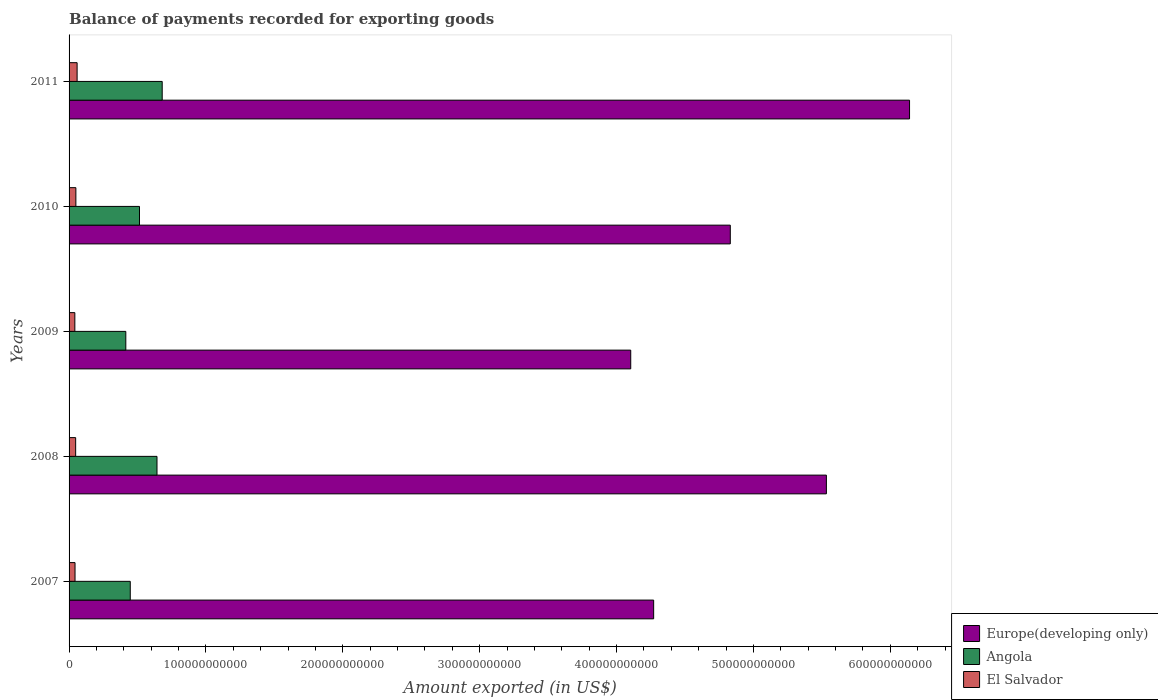How many groups of bars are there?
Give a very brief answer. 5. How many bars are there on the 1st tick from the bottom?
Ensure brevity in your answer.  3. What is the label of the 5th group of bars from the top?
Your answer should be very brief. 2007. In how many cases, is the number of bars for a given year not equal to the number of legend labels?
Make the answer very short. 0. What is the amount exported in Europe(developing only) in 2007?
Your response must be concise. 4.27e+11. Across all years, what is the maximum amount exported in Angola?
Provide a succinct answer. 6.80e+1. Across all years, what is the minimum amount exported in Europe(developing only)?
Provide a short and direct response. 4.10e+11. What is the total amount exported in Europe(developing only) in the graph?
Offer a very short reply. 2.49e+12. What is the difference between the amount exported in Europe(developing only) in 2007 and that in 2009?
Offer a terse response. 1.67e+1. What is the difference between the amount exported in El Salvador in 2010 and the amount exported in Angola in 2008?
Provide a short and direct response. -5.93e+1. What is the average amount exported in Europe(developing only) per year?
Your answer should be compact. 4.98e+11. In the year 2007, what is the difference between the amount exported in Angola and amount exported in El Salvador?
Your answer should be very brief. 4.04e+1. In how many years, is the amount exported in Angola greater than 540000000000 US$?
Provide a succinct answer. 0. What is the ratio of the amount exported in Angola in 2007 to that in 2010?
Offer a very short reply. 0.87. Is the amount exported in Europe(developing only) in 2008 less than that in 2010?
Make the answer very short. No. What is the difference between the highest and the second highest amount exported in El Salvador?
Give a very brief answer. 9.07e+08. What is the difference between the highest and the lowest amount exported in El Salvador?
Make the answer very short. 1.66e+09. In how many years, is the amount exported in Europe(developing only) greater than the average amount exported in Europe(developing only) taken over all years?
Offer a terse response. 2. Is the sum of the amount exported in Europe(developing only) in 2007 and 2009 greater than the maximum amount exported in Angola across all years?
Keep it short and to the point. Yes. What does the 3rd bar from the top in 2008 represents?
Ensure brevity in your answer.  Europe(developing only). What does the 2nd bar from the bottom in 2007 represents?
Provide a succinct answer. Angola. Is it the case that in every year, the sum of the amount exported in El Salvador and amount exported in Angola is greater than the amount exported in Europe(developing only)?
Your answer should be compact. No. What is the difference between two consecutive major ticks on the X-axis?
Your answer should be compact. 1.00e+11. Are the values on the major ticks of X-axis written in scientific E-notation?
Keep it short and to the point. No. Does the graph contain any zero values?
Keep it short and to the point. No. How many legend labels are there?
Ensure brevity in your answer.  3. How are the legend labels stacked?
Make the answer very short. Vertical. What is the title of the graph?
Make the answer very short. Balance of payments recorded for exporting goods. Does "Guinea-Bissau" appear as one of the legend labels in the graph?
Your response must be concise. No. What is the label or title of the X-axis?
Offer a very short reply. Amount exported (in US$). What is the label or title of the Y-axis?
Keep it short and to the point. Years. What is the Amount exported (in US$) of Europe(developing only) in 2007?
Provide a succinct answer. 4.27e+11. What is the Amount exported (in US$) of Angola in 2007?
Keep it short and to the point. 4.47e+1. What is the Amount exported (in US$) in El Salvador in 2007?
Keep it short and to the point. 4.35e+09. What is the Amount exported (in US$) of Europe(developing only) in 2008?
Your answer should be very brief. 5.53e+11. What is the Amount exported (in US$) of Angola in 2008?
Provide a succinct answer. 6.42e+1. What is the Amount exported (in US$) in El Salvador in 2008?
Offer a very short reply. 4.81e+09. What is the Amount exported (in US$) in Europe(developing only) in 2009?
Give a very brief answer. 4.10e+11. What is the Amount exported (in US$) of Angola in 2009?
Your answer should be very brief. 4.15e+1. What is the Amount exported (in US$) in El Salvador in 2009?
Provide a succinct answer. 4.22e+09. What is the Amount exported (in US$) in Europe(developing only) in 2010?
Your response must be concise. 4.83e+11. What is the Amount exported (in US$) in Angola in 2010?
Provide a short and direct response. 5.15e+1. What is the Amount exported (in US$) in El Salvador in 2010?
Your answer should be very brief. 4.97e+09. What is the Amount exported (in US$) of Europe(developing only) in 2011?
Ensure brevity in your answer.  6.14e+11. What is the Amount exported (in US$) of Angola in 2011?
Your answer should be compact. 6.80e+1. What is the Amount exported (in US$) in El Salvador in 2011?
Keep it short and to the point. 5.88e+09. Across all years, what is the maximum Amount exported (in US$) of Europe(developing only)?
Your answer should be compact. 6.14e+11. Across all years, what is the maximum Amount exported (in US$) in Angola?
Make the answer very short. 6.80e+1. Across all years, what is the maximum Amount exported (in US$) of El Salvador?
Keep it short and to the point. 5.88e+09. Across all years, what is the minimum Amount exported (in US$) of Europe(developing only)?
Your answer should be very brief. 4.10e+11. Across all years, what is the minimum Amount exported (in US$) in Angola?
Offer a terse response. 4.15e+1. Across all years, what is the minimum Amount exported (in US$) of El Salvador?
Give a very brief answer. 4.22e+09. What is the total Amount exported (in US$) in Europe(developing only) in the graph?
Provide a short and direct response. 2.49e+12. What is the total Amount exported (in US$) of Angola in the graph?
Give a very brief answer. 2.70e+11. What is the total Amount exported (in US$) of El Salvador in the graph?
Make the answer very short. 2.42e+1. What is the difference between the Amount exported (in US$) of Europe(developing only) in 2007 and that in 2008?
Make the answer very short. -1.26e+11. What is the difference between the Amount exported (in US$) of Angola in 2007 and that in 2008?
Provide a short and direct response. -1.95e+1. What is the difference between the Amount exported (in US$) in El Salvador in 2007 and that in 2008?
Your answer should be very brief. -4.60e+08. What is the difference between the Amount exported (in US$) in Europe(developing only) in 2007 and that in 2009?
Offer a very short reply. 1.67e+1. What is the difference between the Amount exported (in US$) in Angola in 2007 and that in 2009?
Offer a terse response. 3.26e+09. What is the difference between the Amount exported (in US$) of El Salvador in 2007 and that in 2009?
Offer a terse response. 1.34e+08. What is the difference between the Amount exported (in US$) of Europe(developing only) in 2007 and that in 2010?
Keep it short and to the point. -5.60e+1. What is the difference between the Amount exported (in US$) in Angola in 2007 and that in 2010?
Provide a succinct answer. -6.74e+09. What is the difference between the Amount exported (in US$) in El Salvador in 2007 and that in 2010?
Provide a succinct answer. -6.22e+08. What is the difference between the Amount exported (in US$) of Europe(developing only) in 2007 and that in 2011?
Give a very brief answer. -1.87e+11. What is the difference between the Amount exported (in US$) in Angola in 2007 and that in 2011?
Your answer should be very brief. -2.33e+1. What is the difference between the Amount exported (in US$) of El Salvador in 2007 and that in 2011?
Provide a succinct answer. -1.53e+09. What is the difference between the Amount exported (in US$) in Europe(developing only) in 2008 and that in 2009?
Provide a short and direct response. 1.43e+11. What is the difference between the Amount exported (in US$) of Angola in 2008 and that in 2009?
Ensure brevity in your answer.  2.28e+1. What is the difference between the Amount exported (in US$) of El Salvador in 2008 and that in 2009?
Your response must be concise. 5.94e+08. What is the difference between the Amount exported (in US$) in Europe(developing only) in 2008 and that in 2010?
Provide a succinct answer. 7.02e+1. What is the difference between the Amount exported (in US$) of Angola in 2008 and that in 2010?
Your response must be concise. 1.28e+1. What is the difference between the Amount exported (in US$) in El Salvador in 2008 and that in 2010?
Your response must be concise. -1.61e+08. What is the difference between the Amount exported (in US$) of Europe(developing only) in 2008 and that in 2011?
Make the answer very short. -6.08e+1. What is the difference between the Amount exported (in US$) of Angola in 2008 and that in 2011?
Keep it short and to the point. -3.80e+09. What is the difference between the Amount exported (in US$) of El Salvador in 2008 and that in 2011?
Provide a succinct answer. -1.07e+09. What is the difference between the Amount exported (in US$) in Europe(developing only) in 2009 and that in 2010?
Keep it short and to the point. -7.27e+1. What is the difference between the Amount exported (in US$) of Angola in 2009 and that in 2010?
Your answer should be compact. -1.00e+1. What is the difference between the Amount exported (in US$) in El Salvador in 2009 and that in 2010?
Your answer should be very brief. -7.55e+08. What is the difference between the Amount exported (in US$) in Europe(developing only) in 2009 and that in 2011?
Your answer should be compact. -2.04e+11. What is the difference between the Amount exported (in US$) of Angola in 2009 and that in 2011?
Offer a very short reply. -2.66e+1. What is the difference between the Amount exported (in US$) in El Salvador in 2009 and that in 2011?
Your response must be concise. -1.66e+09. What is the difference between the Amount exported (in US$) of Europe(developing only) in 2010 and that in 2011?
Give a very brief answer. -1.31e+11. What is the difference between the Amount exported (in US$) of Angola in 2010 and that in 2011?
Offer a terse response. -1.66e+1. What is the difference between the Amount exported (in US$) of El Salvador in 2010 and that in 2011?
Your response must be concise. -9.07e+08. What is the difference between the Amount exported (in US$) in Europe(developing only) in 2007 and the Amount exported (in US$) in Angola in 2008?
Provide a succinct answer. 3.63e+11. What is the difference between the Amount exported (in US$) of Europe(developing only) in 2007 and the Amount exported (in US$) of El Salvador in 2008?
Provide a succinct answer. 4.22e+11. What is the difference between the Amount exported (in US$) of Angola in 2007 and the Amount exported (in US$) of El Salvador in 2008?
Provide a succinct answer. 3.99e+1. What is the difference between the Amount exported (in US$) in Europe(developing only) in 2007 and the Amount exported (in US$) in Angola in 2009?
Offer a terse response. 3.86e+11. What is the difference between the Amount exported (in US$) of Europe(developing only) in 2007 and the Amount exported (in US$) of El Salvador in 2009?
Offer a very short reply. 4.23e+11. What is the difference between the Amount exported (in US$) of Angola in 2007 and the Amount exported (in US$) of El Salvador in 2009?
Your response must be concise. 4.05e+1. What is the difference between the Amount exported (in US$) in Europe(developing only) in 2007 and the Amount exported (in US$) in Angola in 2010?
Ensure brevity in your answer.  3.76e+11. What is the difference between the Amount exported (in US$) of Europe(developing only) in 2007 and the Amount exported (in US$) of El Salvador in 2010?
Your answer should be compact. 4.22e+11. What is the difference between the Amount exported (in US$) of Angola in 2007 and the Amount exported (in US$) of El Salvador in 2010?
Offer a very short reply. 3.97e+1. What is the difference between the Amount exported (in US$) of Europe(developing only) in 2007 and the Amount exported (in US$) of Angola in 2011?
Offer a very short reply. 3.59e+11. What is the difference between the Amount exported (in US$) of Europe(developing only) in 2007 and the Amount exported (in US$) of El Salvador in 2011?
Offer a very short reply. 4.21e+11. What is the difference between the Amount exported (in US$) in Angola in 2007 and the Amount exported (in US$) in El Salvador in 2011?
Offer a terse response. 3.88e+1. What is the difference between the Amount exported (in US$) in Europe(developing only) in 2008 and the Amount exported (in US$) in Angola in 2009?
Ensure brevity in your answer.  5.12e+11. What is the difference between the Amount exported (in US$) in Europe(developing only) in 2008 and the Amount exported (in US$) in El Salvador in 2009?
Your answer should be very brief. 5.49e+11. What is the difference between the Amount exported (in US$) in Angola in 2008 and the Amount exported (in US$) in El Salvador in 2009?
Give a very brief answer. 6.00e+1. What is the difference between the Amount exported (in US$) of Europe(developing only) in 2008 and the Amount exported (in US$) of Angola in 2010?
Offer a terse response. 5.02e+11. What is the difference between the Amount exported (in US$) of Europe(developing only) in 2008 and the Amount exported (in US$) of El Salvador in 2010?
Offer a terse response. 5.48e+11. What is the difference between the Amount exported (in US$) of Angola in 2008 and the Amount exported (in US$) of El Salvador in 2010?
Keep it short and to the point. 5.93e+1. What is the difference between the Amount exported (in US$) of Europe(developing only) in 2008 and the Amount exported (in US$) of Angola in 2011?
Your answer should be very brief. 4.85e+11. What is the difference between the Amount exported (in US$) in Europe(developing only) in 2008 and the Amount exported (in US$) in El Salvador in 2011?
Your answer should be compact. 5.47e+11. What is the difference between the Amount exported (in US$) in Angola in 2008 and the Amount exported (in US$) in El Salvador in 2011?
Offer a very short reply. 5.84e+1. What is the difference between the Amount exported (in US$) in Europe(developing only) in 2009 and the Amount exported (in US$) in Angola in 2010?
Provide a succinct answer. 3.59e+11. What is the difference between the Amount exported (in US$) in Europe(developing only) in 2009 and the Amount exported (in US$) in El Salvador in 2010?
Offer a terse response. 4.05e+11. What is the difference between the Amount exported (in US$) of Angola in 2009 and the Amount exported (in US$) of El Salvador in 2010?
Offer a very short reply. 3.65e+1. What is the difference between the Amount exported (in US$) of Europe(developing only) in 2009 and the Amount exported (in US$) of Angola in 2011?
Give a very brief answer. 3.42e+11. What is the difference between the Amount exported (in US$) in Europe(developing only) in 2009 and the Amount exported (in US$) in El Salvador in 2011?
Your answer should be very brief. 4.04e+11. What is the difference between the Amount exported (in US$) of Angola in 2009 and the Amount exported (in US$) of El Salvador in 2011?
Your response must be concise. 3.56e+1. What is the difference between the Amount exported (in US$) of Europe(developing only) in 2010 and the Amount exported (in US$) of Angola in 2011?
Keep it short and to the point. 4.15e+11. What is the difference between the Amount exported (in US$) of Europe(developing only) in 2010 and the Amount exported (in US$) of El Salvador in 2011?
Your answer should be very brief. 4.77e+11. What is the difference between the Amount exported (in US$) of Angola in 2010 and the Amount exported (in US$) of El Salvador in 2011?
Offer a very short reply. 4.56e+1. What is the average Amount exported (in US$) in Europe(developing only) per year?
Make the answer very short. 4.98e+11. What is the average Amount exported (in US$) of Angola per year?
Offer a terse response. 5.40e+1. What is the average Amount exported (in US$) in El Salvador per year?
Provide a succinct answer. 4.84e+09. In the year 2007, what is the difference between the Amount exported (in US$) of Europe(developing only) and Amount exported (in US$) of Angola?
Your answer should be compact. 3.82e+11. In the year 2007, what is the difference between the Amount exported (in US$) in Europe(developing only) and Amount exported (in US$) in El Salvador?
Keep it short and to the point. 4.23e+11. In the year 2007, what is the difference between the Amount exported (in US$) of Angola and Amount exported (in US$) of El Salvador?
Ensure brevity in your answer.  4.04e+1. In the year 2008, what is the difference between the Amount exported (in US$) in Europe(developing only) and Amount exported (in US$) in Angola?
Keep it short and to the point. 4.89e+11. In the year 2008, what is the difference between the Amount exported (in US$) of Europe(developing only) and Amount exported (in US$) of El Salvador?
Offer a terse response. 5.48e+11. In the year 2008, what is the difference between the Amount exported (in US$) of Angola and Amount exported (in US$) of El Salvador?
Make the answer very short. 5.94e+1. In the year 2009, what is the difference between the Amount exported (in US$) of Europe(developing only) and Amount exported (in US$) of Angola?
Keep it short and to the point. 3.69e+11. In the year 2009, what is the difference between the Amount exported (in US$) of Europe(developing only) and Amount exported (in US$) of El Salvador?
Your response must be concise. 4.06e+11. In the year 2009, what is the difference between the Amount exported (in US$) of Angola and Amount exported (in US$) of El Salvador?
Offer a terse response. 3.72e+1. In the year 2010, what is the difference between the Amount exported (in US$) in Europe(developing only) and Amount exported (in US$) in Angola?
Offer a terse response. 4.32e+11. In the year 2010, what is the difference between the Amount exported (in US$) of Europe(developing only) and Amount exported (in US$) of El Salvador?
Give a very brief answer. 4.78e+11. In the year 2010, what is the difference between the Amount exported (in US$) in Angola and Amount exported (in US$) in El Salvador?
Your answer should be compact. 4.65e+1. In the year 2011, what is the difference between the Amount exported (in US$) in Europe(developing only) and Amount exported (in US$) in Angola?
Provide a succinct answer. 5.46e+11. In the year 2011, what is the difference between the Amount exported (in US$) in Europe(developing only) and Amount exported (in US$) in El Salvador?
Your answer should be compact. 6.08e+11. In the year 2011, what is the difference between the Amount exported (in US$) in Angola and Amount exported (in US$) in El Salvador?
Keep it short and to the point. 6.22e+1. What is the ratio of the Amount exported (in US$) of Europe(developing only) in 2007 to that in 2008?
Make the answer very short. 0.77. What is the ratio of the Amount exported (in US$) in Angola in 2007 to that in 2008?
Make the answer very short. 0.7. What is the ratio of the Amount exported (in US$) of El Salvador in 2007 to that in 2008?
Give a very brief answer. 0.9. What is the ratio of the Amount exported (in US$) in Europe(developing only) in 2007 to that in 2009?
Your answer should be very brief. 1.04. What is the ratio of the Amount exported (in US$) of Angola in 2007 to that in 2009?
Ensure brevity in your answer.  1.08. What is the ratio of the Amount exported (in US$) in El Salvador in 2007 to that in 2009?
Your response must be concise. 1.03. What is the ratio of the Amount exported (in US$) in Europe(developing only) in 2007 to that in 2010?
Provide a succinct answer. 0.88. What is the ratio of the Amount exported (in US$) in Angola in 2007 to that in 2010?
Make the answer very short. 0.87. What is the ratio of the Amount exported (in US$) of El Salvador in 2007 to that in 2010?
Provide a succinct answer. 0.87. What is the ratio of the Amount exported (in US$) in Europe(developing only) in 2007 to that in 2011?
Make the answer very short. 0.7. What is the ratio of the Amount exported (in US$) in Angola in 2007 to that in 2011?
Offer a terse response. 0.66. What is the ratio of the Amount exported (in US$) in El Salvador in 2007 to that in 2011?
Your answer should be very brief. 0.74. What is the ratio of the Amount exported (in US$) of Europe(developing only) in 2008 to that in 2009?
Give a very brief answer. 1.35. What is the ratio of the Amount exported (in US$) in Angola in 2008 to that in 2009?
Give a very brief answer. 1.55. What is the ratio of the Amount exported (in US$) of El Salvador in 2008 to that in 2009?
Offer a very short reply. 1.14. What is the ratio of the Amount exported (in US$) of Europe(developing only) in 2008 to that in 2010?
Give a very brief answer. 1.15. What is the ratio of the Amount exported (in US$) in Angola in 2008 to that in 2010?
Ensure brevity in your answer.  1.25. What is the ratio of the Amount exported (in US$) in El Salvador in 2008 to that in 2010?
Your response must be concise. 0.97. What is the ratio of the Amount exported (in US$) in Europe(developing only) in 2008 to that in 2011?
Ensure brevity in your answer.  0.9. What is the ratio of the Amount exported (in US$) in Angola in 2008 to that in 2011?
Give a very brief answer. 0.94. What is the ratio of the Amount exported (in US$) in El Salvador in 2008 to that in 2011?
Give a very brief answer. 0.82. What is the ratio of the Amount exported (in US$) in Europe(developing only) in 2009 to that in 2010?
Offer a very short reply. 0.85. What is the ratio of the Amount exported (in US$) in Angola in 2009 to that in 2010?
Keep it short and to the point. 0.81. What is the ratio of the Amount exported (in US$) of El Salvador in 2009 to that in 2010?
Provide a succinct answer. 0.85. What is the ratio of the Amount exported (in US$) in Europe(developing only) in 2009 to that in 2011?
Offer a terse response. 0.67. What is the ratio of the Amount exported (in US$) in Angola in 2009 to that in 2011?
Give a very brief answer. 0.61. What is the ratio of the Amount exported (in US$) of El Salvador in 2009 to that in 2011?
Your response must be concise. 0.72. What is the ratio of the Amount exported (in US$) of Europe(developing only) in 2010 to that in 2011?
Offer a terse response. 0.79. What is the ratio of the Amount exported (in US$) of Angola in 2010 to that in 2011?
Make the answer very short. 0.76. What is the ratio of the Amount exported (in US$) of El Salvador in 2010 to that in 2011?
Your answer should be very brief. 0.85. What is the difference between the highest and the second highest Amount exported (in US$) of Europe(developing only)?
Give a very brief answer. 6.08e+1. What is the difference between the highest and the second highest Amount exported (in US$) in Angola?
Make the answer very short. 3.80e+09. What is the difference between the highest and the second highest Amount exported (in US$) in El Salvador?
Your answer should be compact. 9.07e+08. What is the difference between the highest and the lowest Amount exported (in US$) in Europe(developing only)?
Your response must be concise. 2.04e+11. What is the difference between the highest and the lowest Amount exported (in US$) of Angola?
Your answer should be very brief. 2.66e+1. What is the difference between the highest and the lowest Amount exported (in US$) in El Salvador?
Keep it short and to the point. 1.66e+09. 